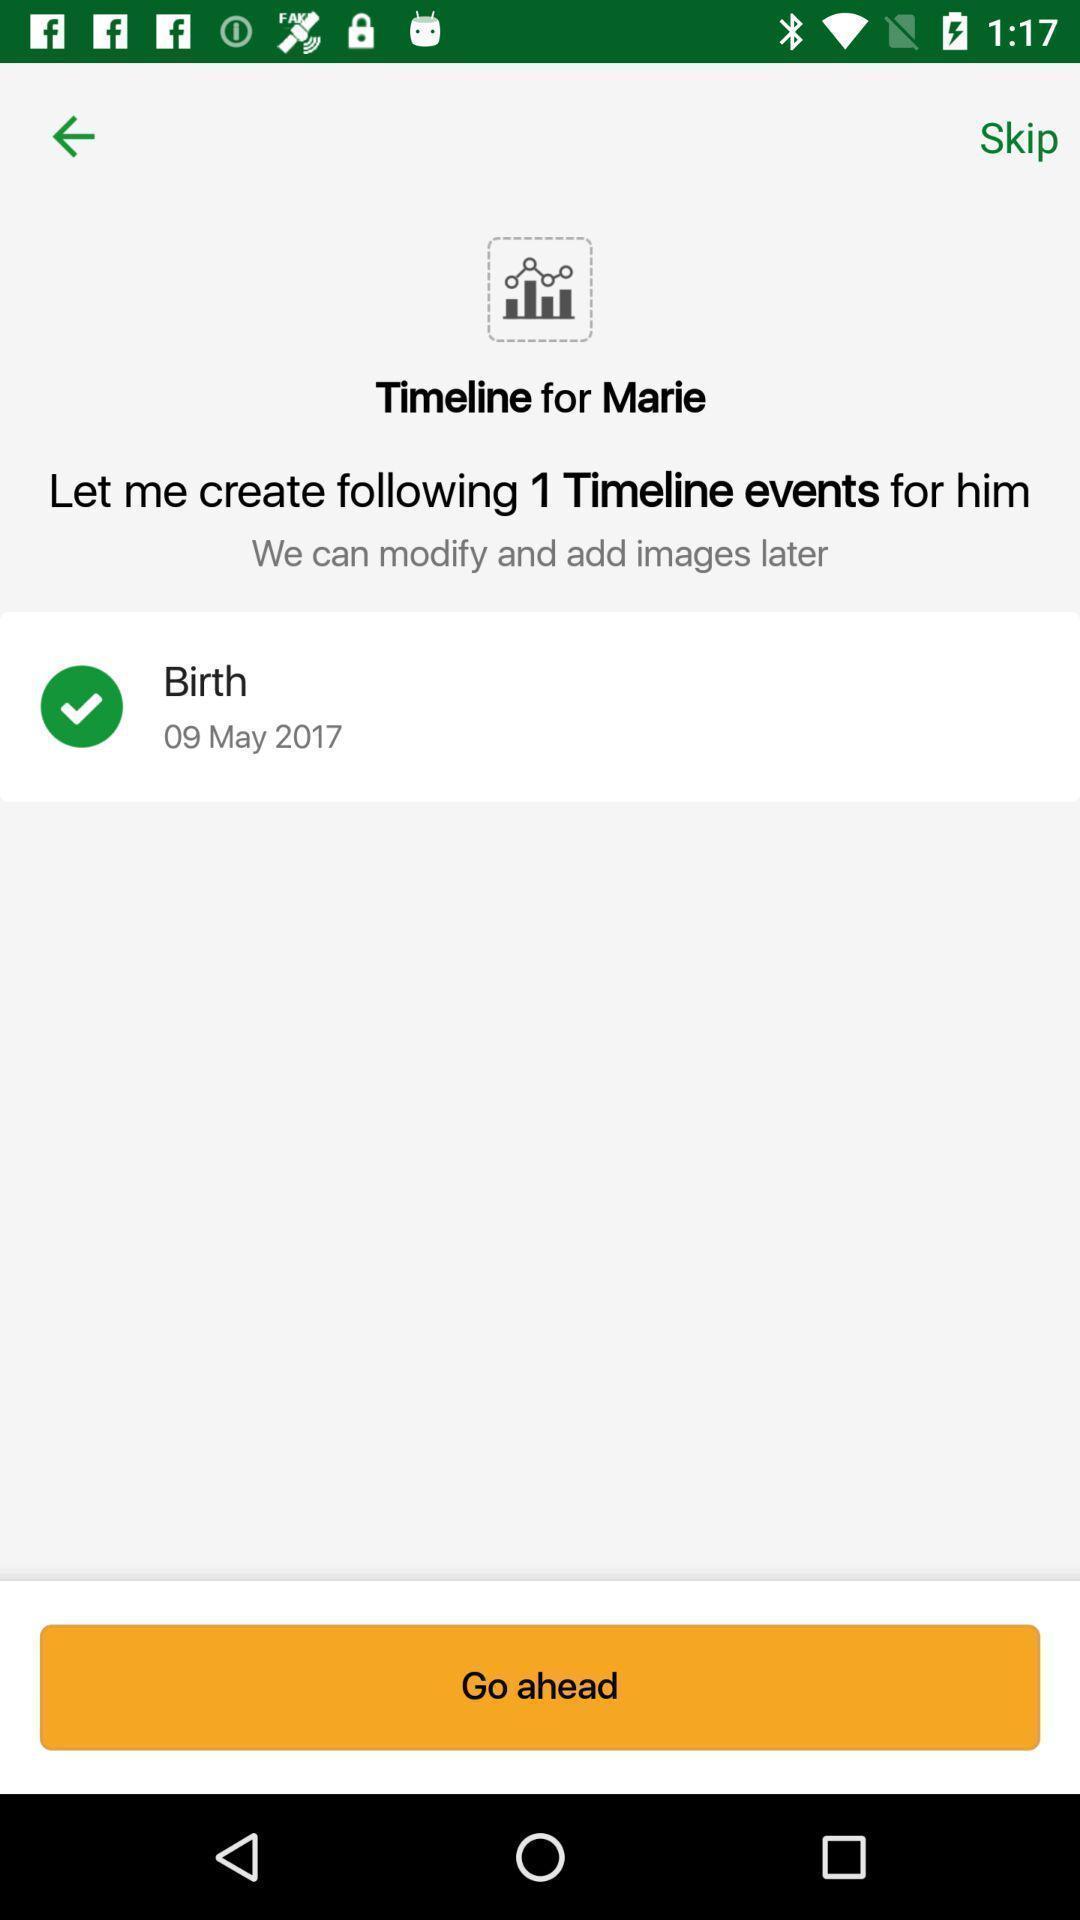Explain the elements present in this screenshot. Page displaying an information with an option. 